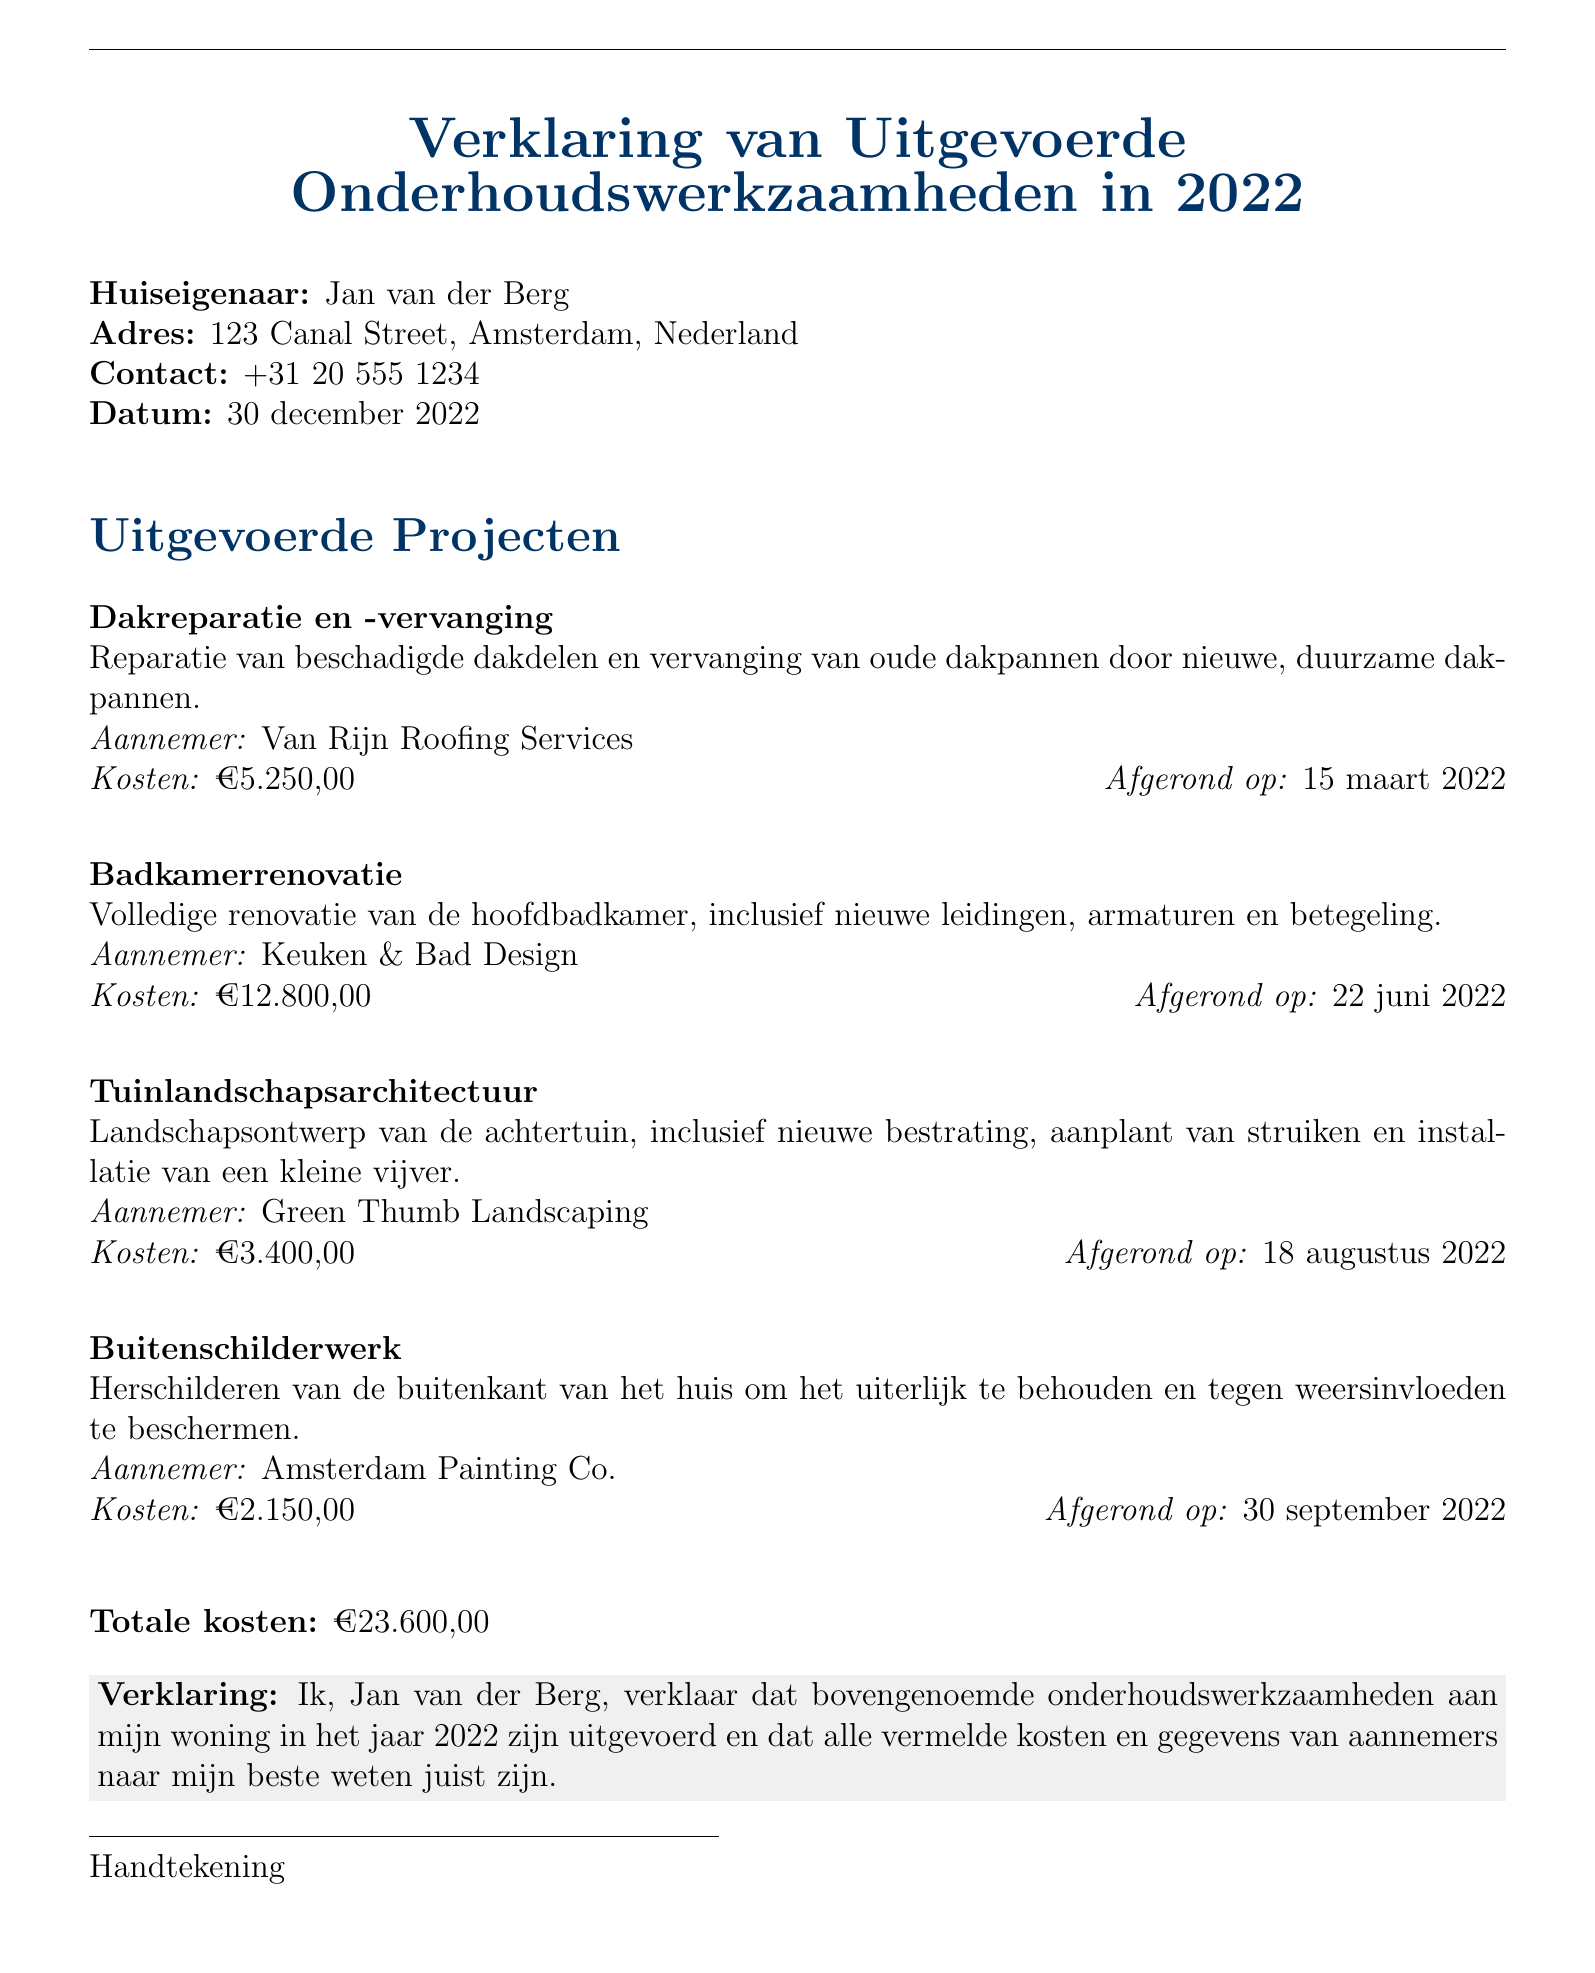Wat is de naam van de huiseigenaar? De naam van de huiseigenaar is vermeld aan het begin van het document.
Answer: Jan van der Berg Wat is het volledige adres van de huiseigenaar? Het volledige adres van de huiseigenaar wordt in de documentatie genoemd.
Answer: 123 Canal Street, Amsterdam, Nederland Wat is de totale kosten van de projecten? De totale kosten zijn aan het einde van het document samengevoegd.
Answer: €23.600,00 Wanneer werd de badkamerrenovatie afgerond? De datum van afronding van de badkamerrenovatie staat naast het project vermeld.
Answer: 22 juni 2022 Wie is de aannemer voor het tuinlandschapsontwerp? De aannemer voor het tuinlandschapsontwerp kan worden gevonden in de projectlijst.
Answer: Green Thumb Landscaping Wat is het kostprijs voor de dakreparatie en -vervanging? De kosten voor dit specifieke project zijn aan het begin van de projectomschrijving te vinden.
Answer: €5.250,00 Wat is de verklaring van de huiseigenaar? De verklaring die de huiseigenaar heeft afgelegd is in de documentatie opgenomen.
Answer: Ik, Jan van der Berg, verklaar dat bovengenoemde onderhoudswerkzaamheden aan mijn woning in het jaar 2022 zijn uitgevoerd Wanneer werd het buitenschilderwerk afgerond? De datum van afronding van het buitenschilderwerk kan worden afgelezen in de projectomschrijving.
Answer: 30 september 2022 Wie heeft de buitenkant van het huis geschilderd? De naam van de aannemer voor het buitenschilderwerk staat in de projectlijst.
Answer: Amsterdam Painting Co 